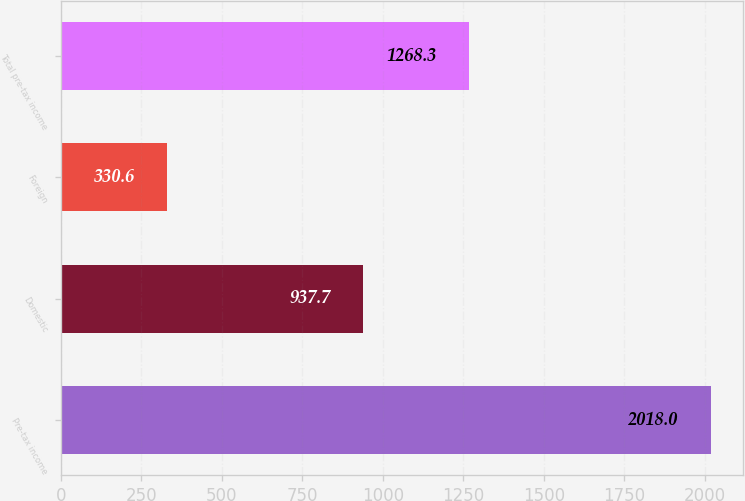Convert chart to OTSL. <chart><loc_0><loc_0><loc_500><loc_500><bar_chart><fcel>Pre-tax income<fcel>Domestic<fcel>Foreign<fcel>Total pre-tax income<nl><fcel>2018<fcel>937.7<fcel>330.6<fcel>1268.3<nl></chart> 